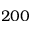Convert formula to latex. <formula><loc_0><loc_0><loc_500><loc_500>2 0 0</formula> 